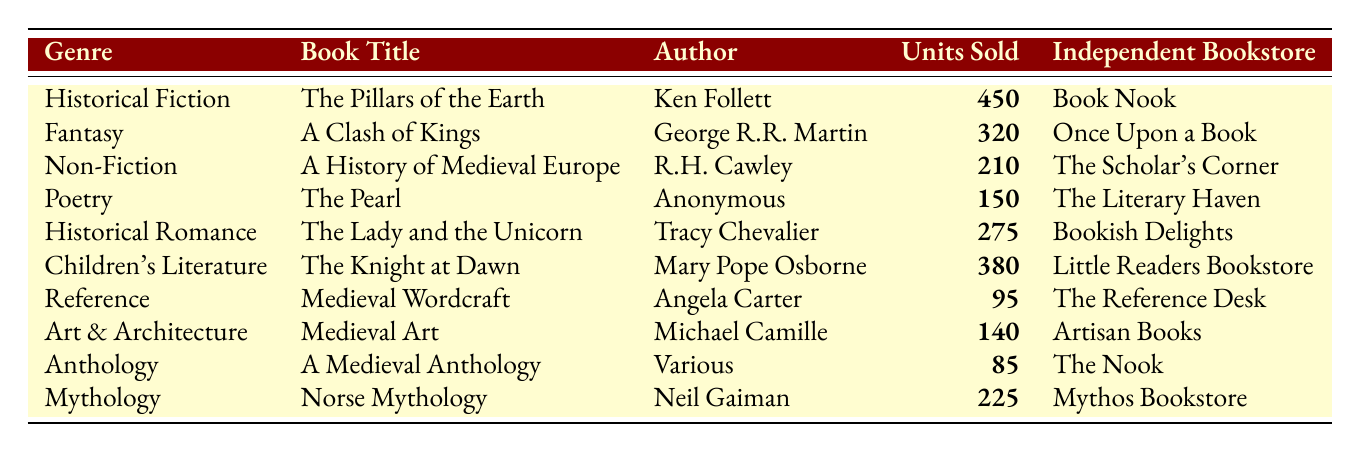What is the book with the highest sales? The book with the highest sales is "The Pillars of the Earth" with 450 units sold.
Answer: The Pillars of the Earth How many units of "The Lady and the Unicorn" were sold? "The Lady and the Unicorn" had 275 units sold listed in the table.
Answer: 275 Which genre sold the least number of books? The genre with the least number of books sold is Anthology, with 85 units sold.
Answer: Anthology What is the total number of medieval-themed books sold across all genres? To find the total, add all units sold: 450 + 320 + 210 + 150 + 275 + 380 + 95 + 140 + 85 + 225 = 2130.
Answer: 2130 How many more units were sold in Historical Fiction compared to Mythology? Historical Fiction sold 450 units while Mythology sold 225 units. The difference is 450 - 225 = 225.
Answer: 225 Is the total number of units sold for Children's Literature greater than 300? Children's Literature sold 380 units, which is greater than 300, so the answer is yes.
Answer: Yes What is the average number of units sold for the books in this table? There are 10 books in total. To calculate the average, sum all units sold (2130) and divide by 10, resulting in an average of 213.
Answer: 213 Which author sold more units, Neil Gaiman or Ken Follett? Ken Follett sold 450 units with "The Pillars of the Earth," while Neil Gaiman sold 225 units with "Norse Mythology." Therefore, Ken Follett sold more.
Answer: Ken Follett What percentage of total sales comes from the genre Fantasy? Fantasy sold 320 units. The percentage is (320/2130) * 100 = approximately 15.04%.
Answer: 15.04% How many books sold were categorized as Reference? The Reference category had only 95 units sold as indicated.
Answer: 95 